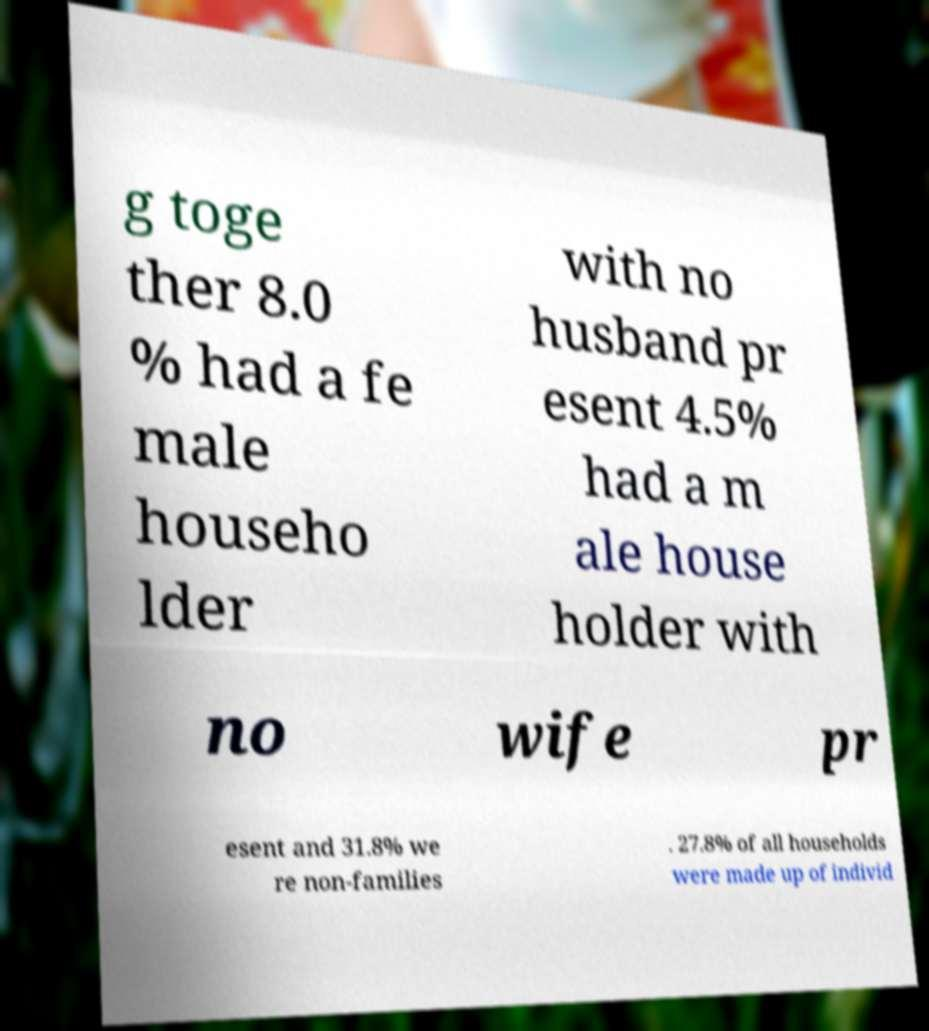I need the written content from this picture converted into text. Can you do that? g toge ther 8.0 % had a fe male househo lder with no husband pr esent 4.5% had a m ale house holder with no wife pr esent and 31.8% we re non-families . 27.8% of all households were made up of individ 